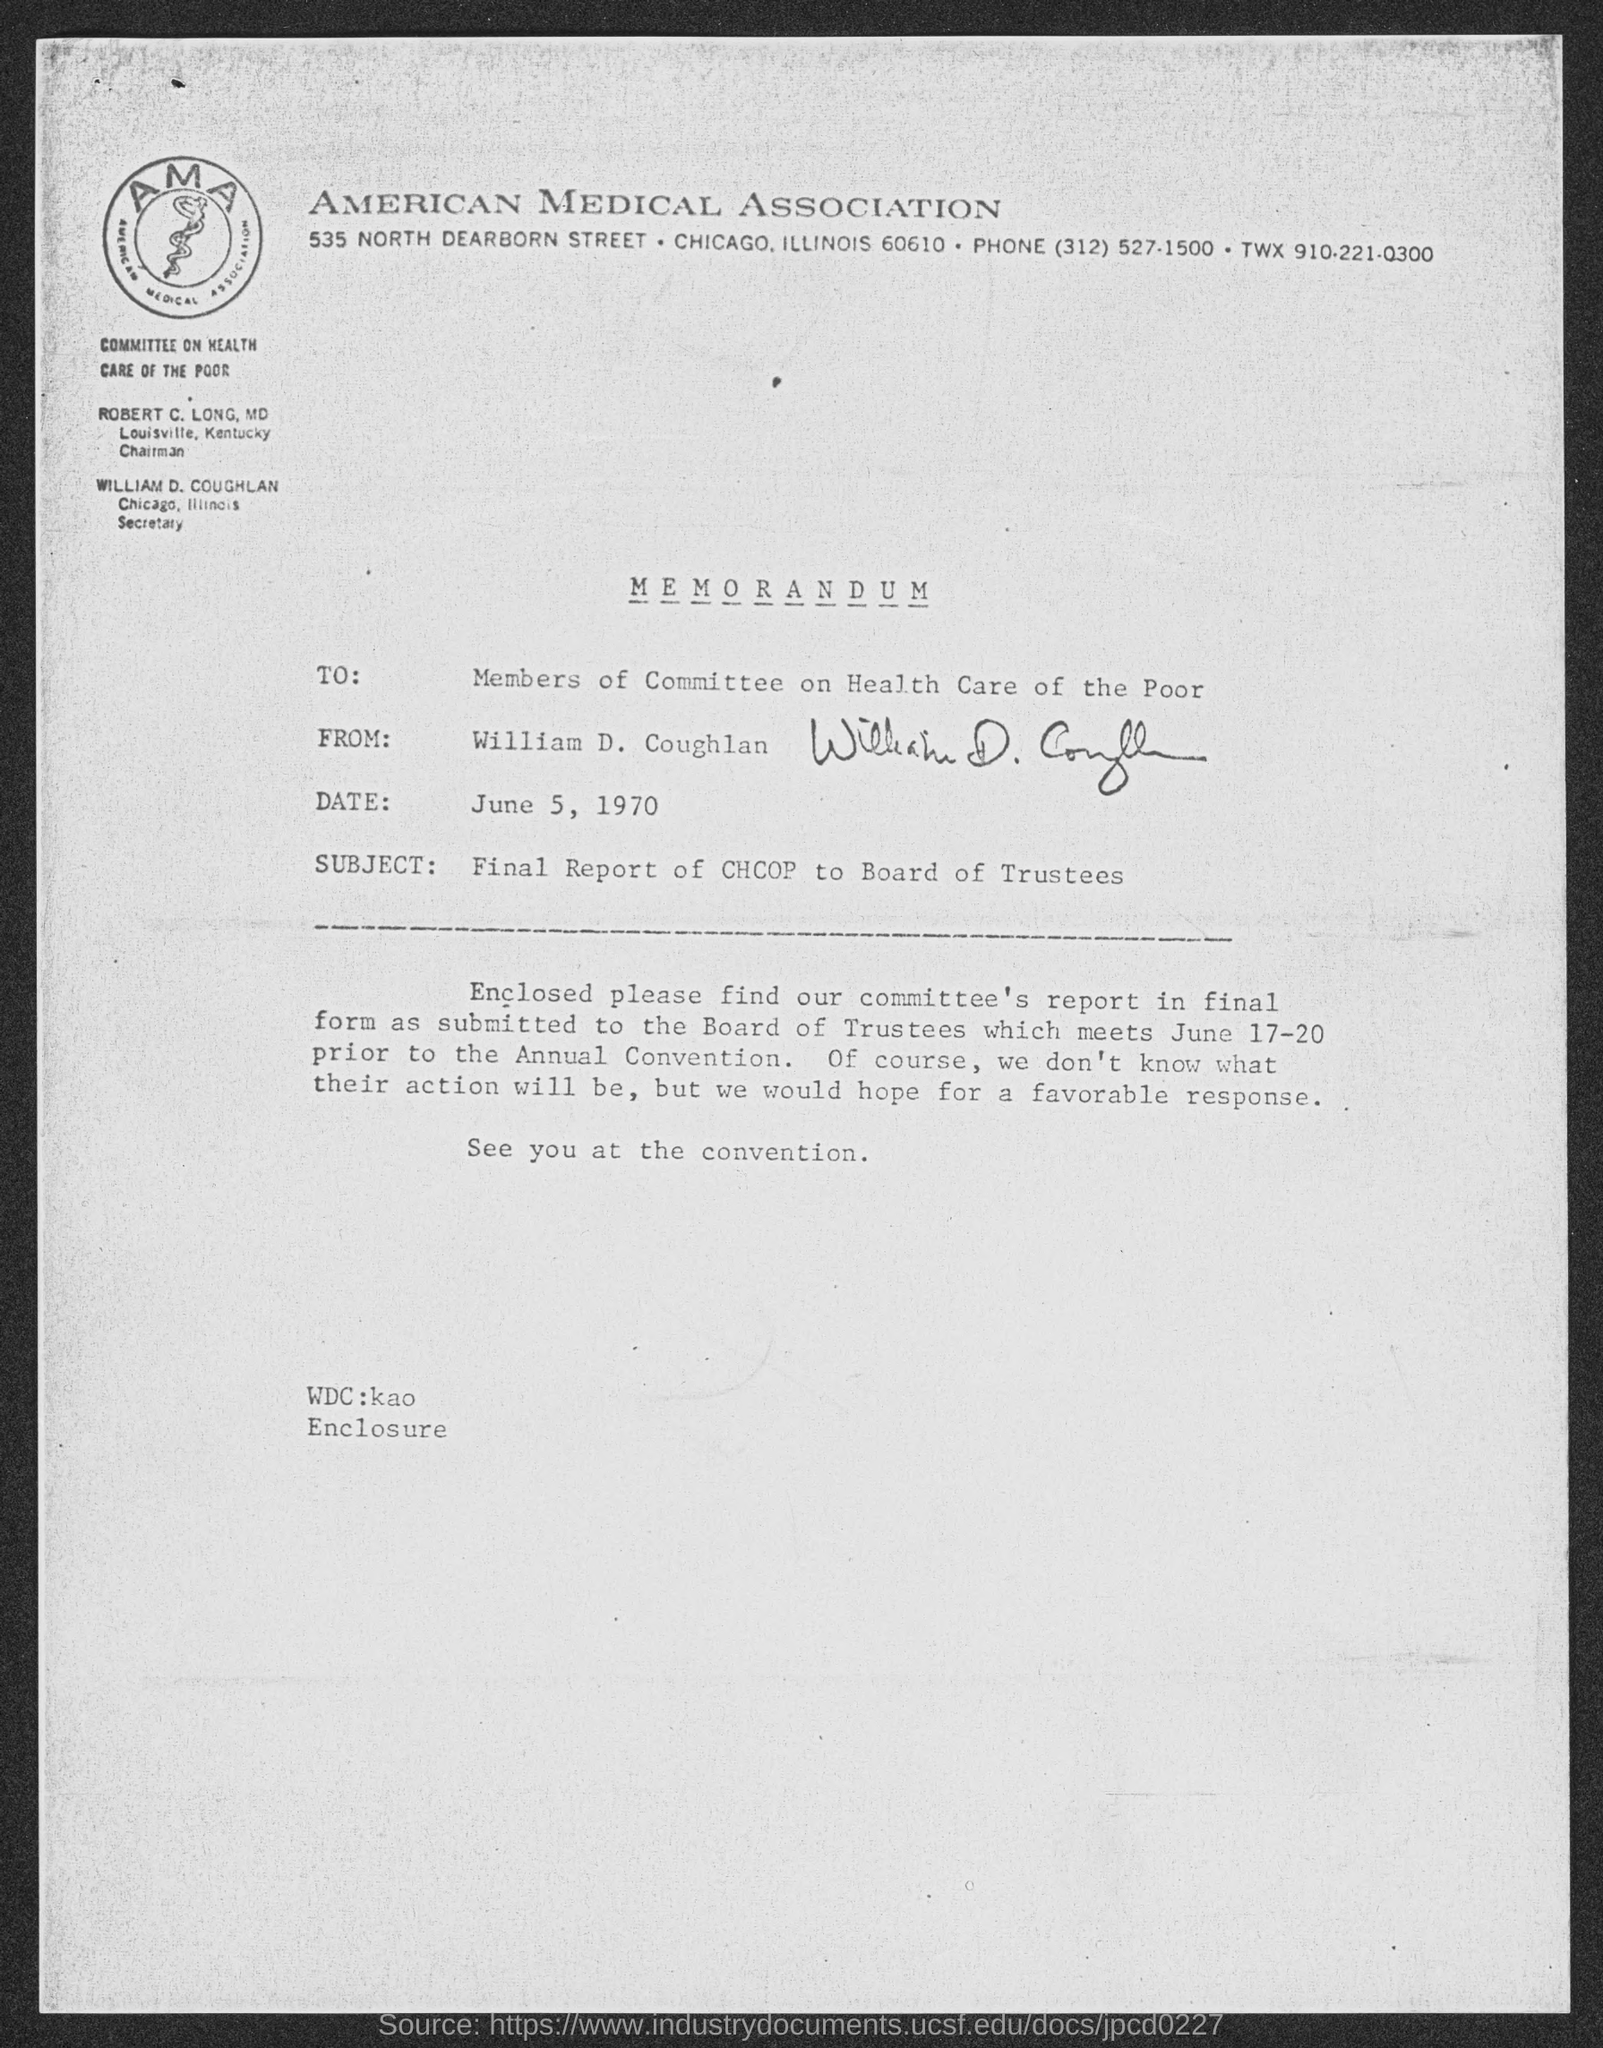Which association is mentioned?
Offer a very short reply. American medical association. What type of documentation is this?
Offer a terse response. MEMORANDUM. To whom is the memorandum addressed?
Your response must be concise. Members of committee on health care of the poor. From whom is the document?
Ensure brevity in your answer.  William D. Coughlan. What is the date given?
Provide a succinct answer. June 5, 1970. What is the subject of the document?
Give a very brief answer. Final Report of CHCOP to Board of Trustees. 